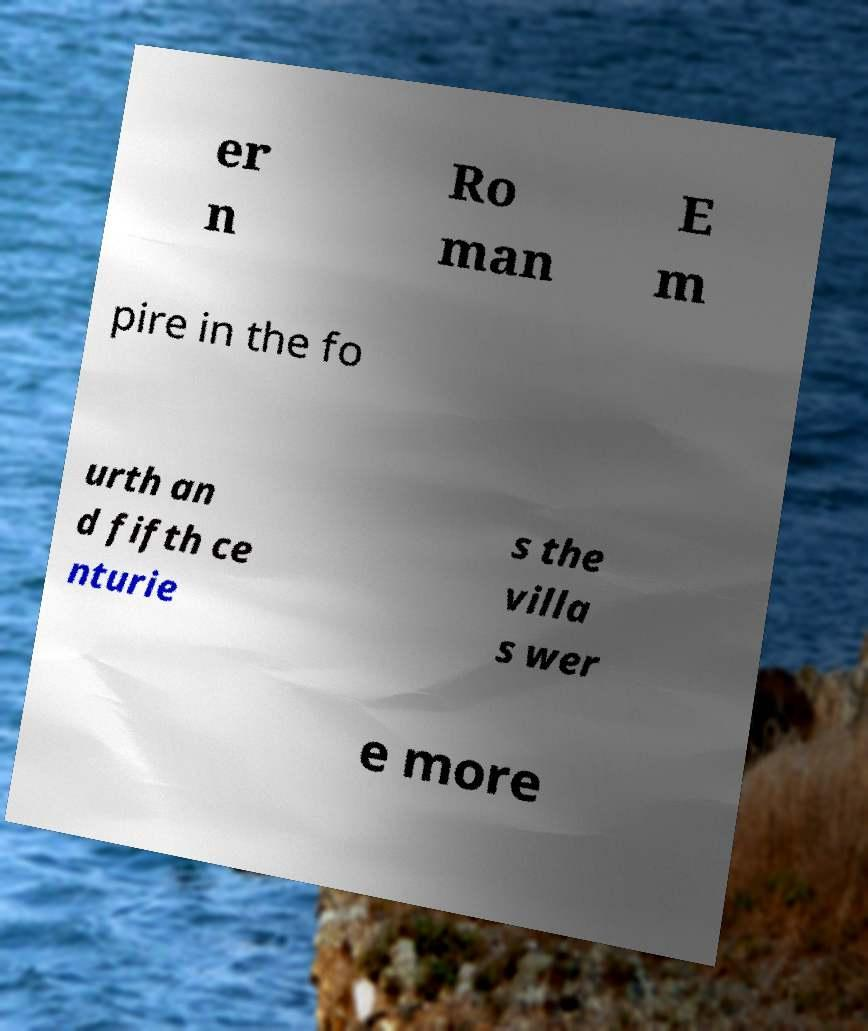For documentation purposes, I need the text within this image transcribed. Could you provide that? er n Ro man E m pire in the fo urth an d fifth ce nturie s the villa s wer e more 